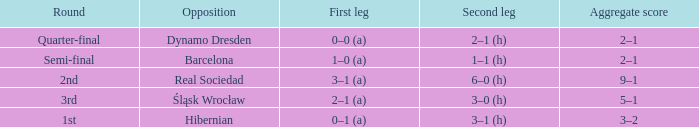What was the first leg score against Real Sociedad? 3–1 (a). 